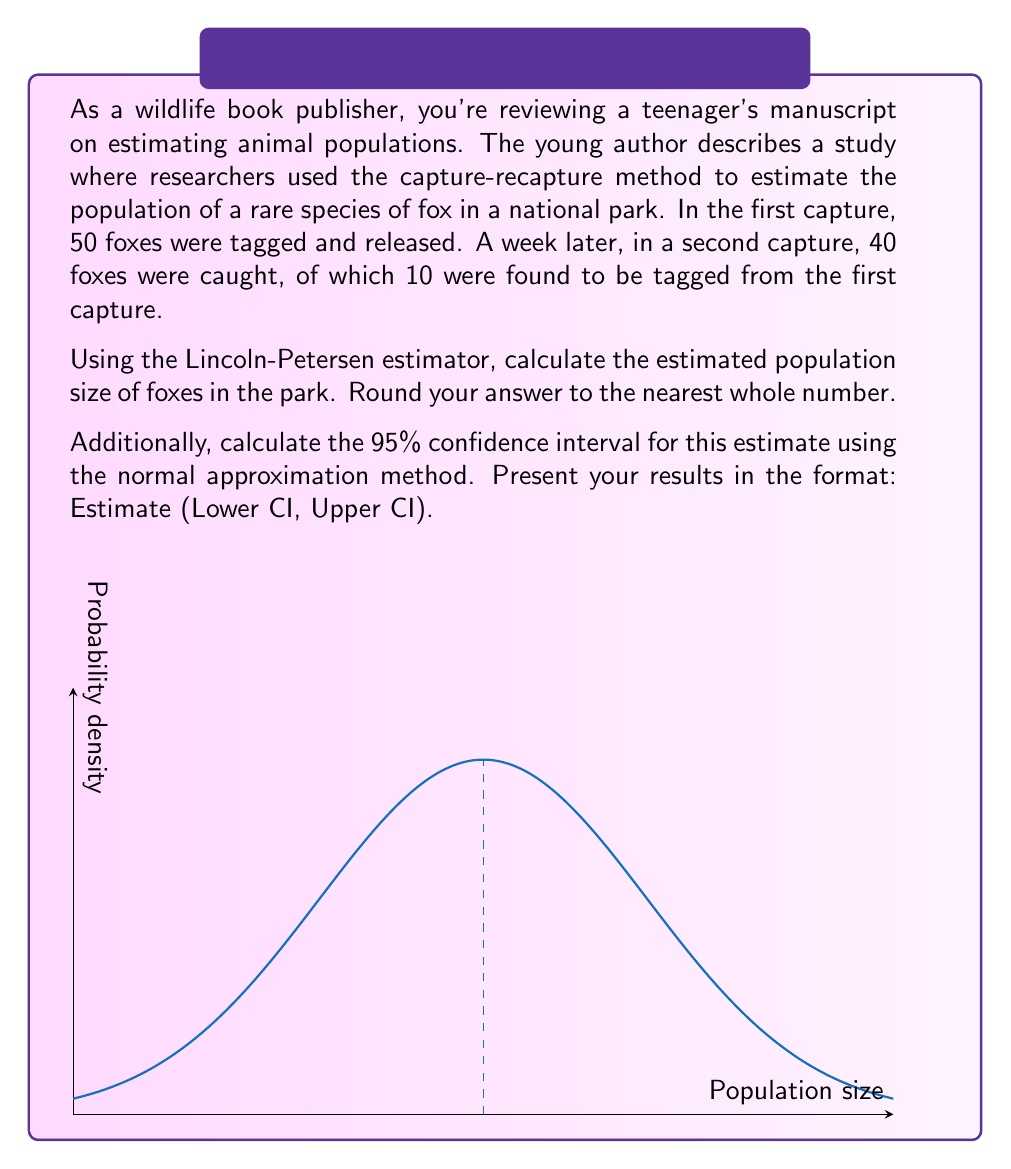Help me with this question. Let's approach this problem step-by-step:

1) The Lincoln-Petersen estimator is given by the formula:

   $$\hat{N} = \frac{M \cdot C}{R}$$

   where $\hat{N}$ is the population estimate, $M$ is the number of animals marked in the first capture, $C$ is the total number of animals in the second capture, and $R$ is the number of recaptured animals (those that were marked).

2) From the given information:
   $M = 50$, $C = 40$, $R = 10$

3) Plugging these values into the formula:

   $$\hat{N} = \frac{50 \cdot 40}{10} = 200$$

4) To calculate the 95% confidence interval, we can use the normal approximation method. The formula for the standard error (SE) of the estimate is:

   $$SE = \sqrt{\frac{\hat{N}^2 \cdot (M-R) \cdot (C-R)}{M^2 \cdot R}}$$

5) Plugging in the values:

   $$SE = \sqrt{\frac{200^2 \cdot (50-10) \cdot (40-10)}{50^2 \cdot 10}} \approx 52.92$$

6) The 95% confidence interval is given by $\hat{N} \pm 1.96 \cdot SE$:

   Lower bound: $200 - 1.96 \cdot 52.92 \approx 96.28$
   Upper bound: $200 + 1.96 \cdot 52.92 \approx 303.72$

7) Rounding to the nearest whole number:

   Estimate: 200
   95% CI: (96, 304)

The graph in the question illustrates a normal distribution centered at the estimate (200), which is a visual representation of the uncertainty in our population estimate.
Answer: 200 (96, 304) 